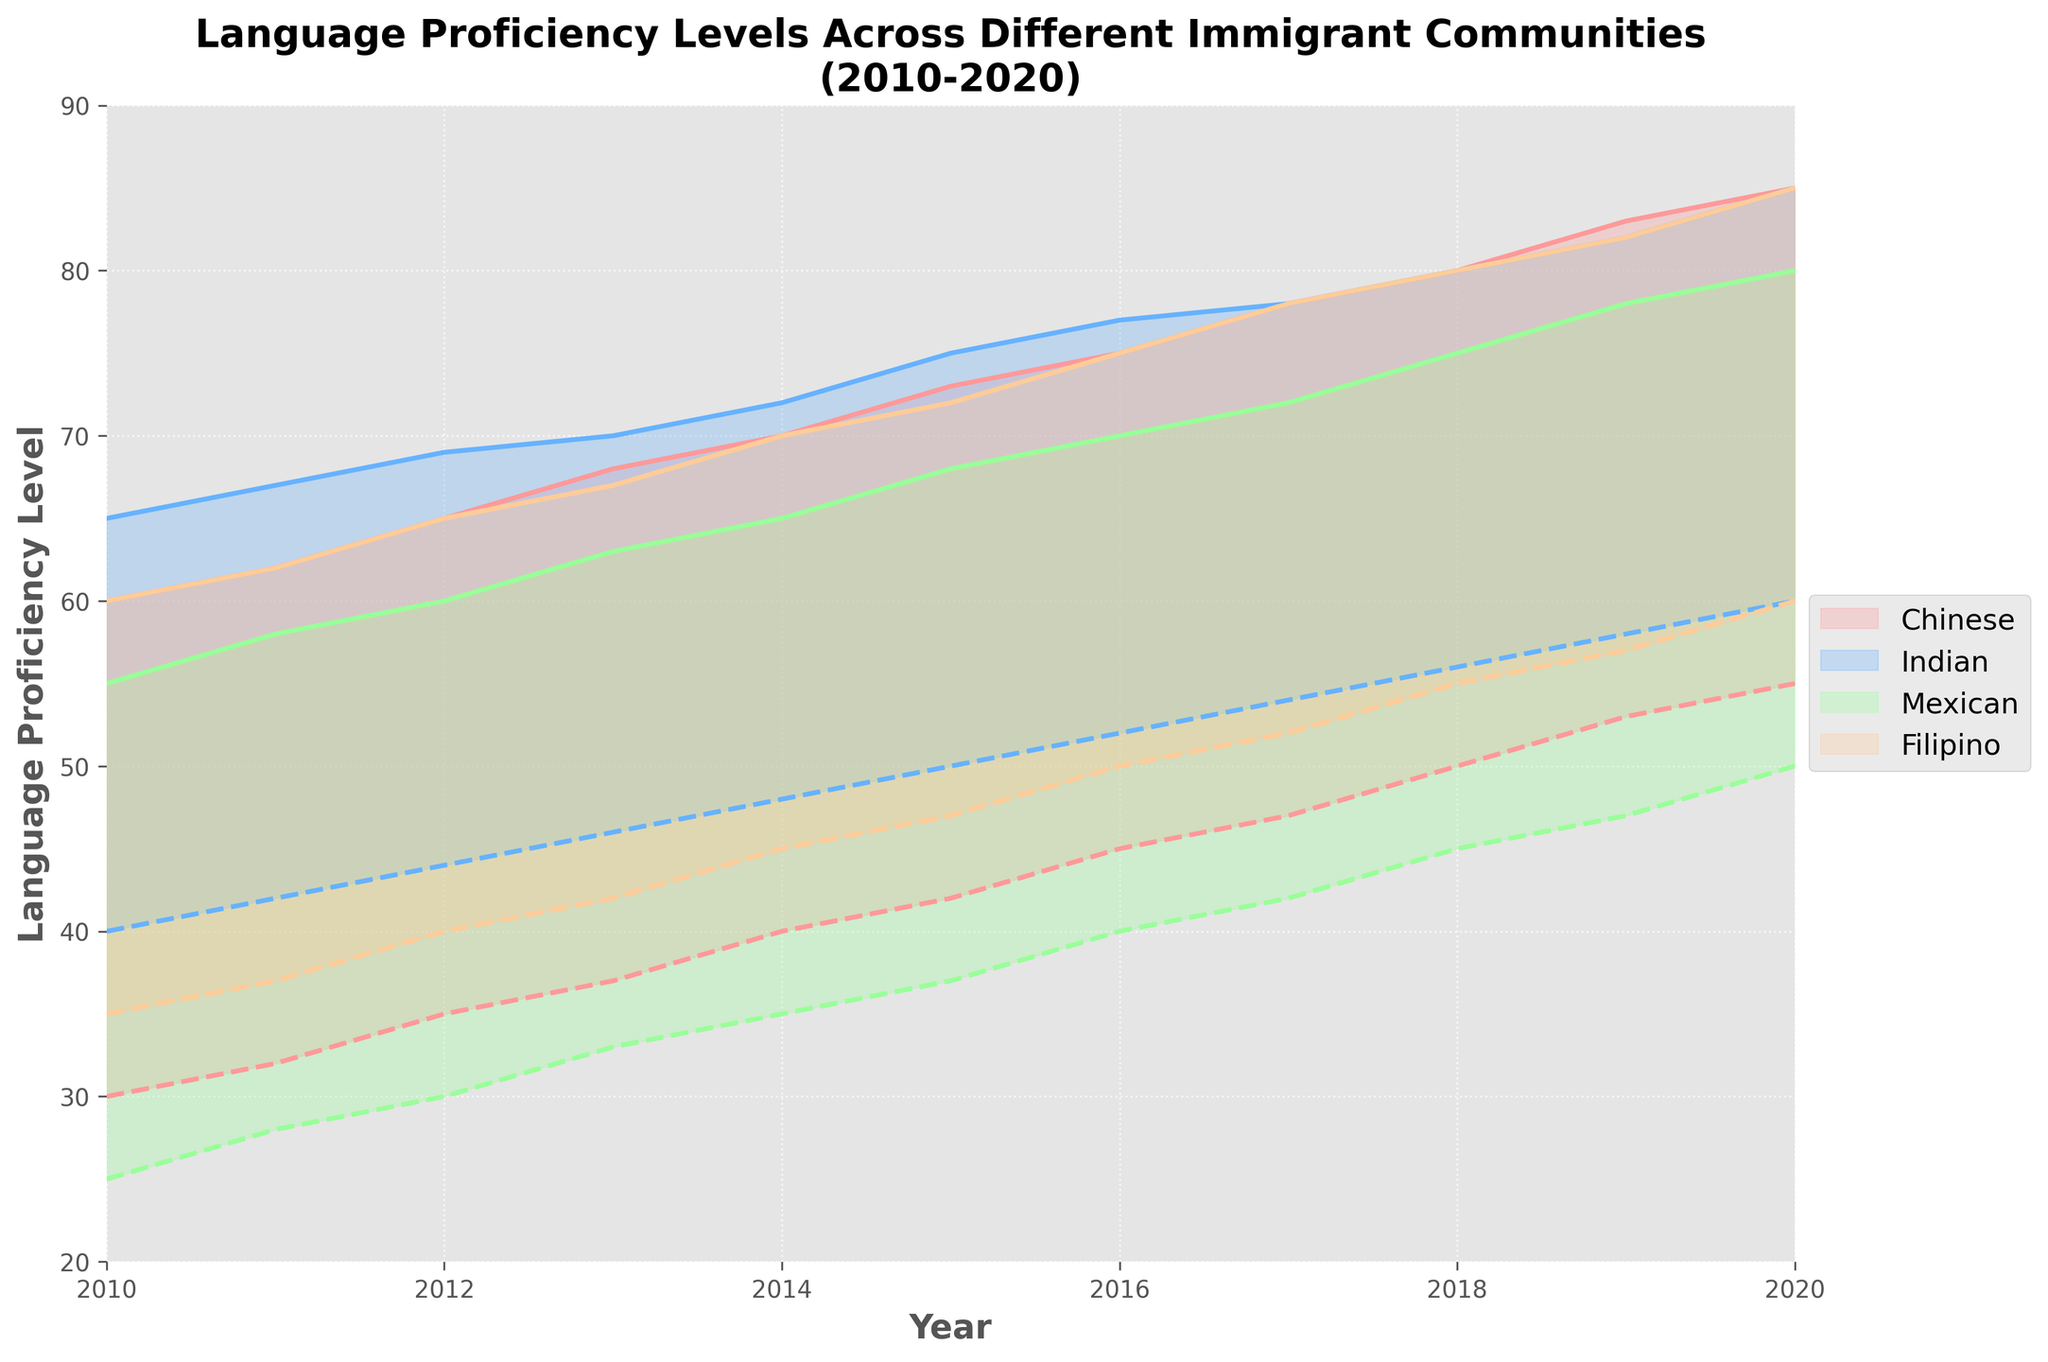What is the title of the chart? The title of the chart is located above the figure and describes the subject of the data being visualized.
Answer: Language Proficiency Levels Across Different Immigrant Communities (2010-2020) What is the range of Mexico’s language proficiency levels in 2015? To find this, locate Mexico on the figure, then find the year 2015. Read the minimum and maximum proficiency levels for this year.
Answer: 37-68 Which community had the highest minimum proficiency level in 2020? To determine this, look for the year 2020 and compare the minimum proficiency levels across all communities. The highest value will indicate the community with the highest minimum proficiency.
Answer: Indian Has the language proficiency level increased or decreased over time for the Chinese community? Observe the trend lines for the minimum and maximum language proficiency levels for the Chinese community from 2010 to 2020. If both lines show an upward trend, proficiency has increased.
Answer: Increased In which year did the proficiency levels for the Filipino community first reach a minimum of 50? Locate the Filipino community's area in the chart and find the year where the bottom of the area representing proficiency levels first intersects or exceeds the value 50.
Answer: 2016 Compare the maximum proficiency level of the Mexican community with the minimum proficiency level of the Chinese community in 2017. Which one is higher? Locate the year 2017, then find and compare the maximum value for the Mexican community and the minimum value for the Chinese community.
Answer: Mexican (72 vs 47) 